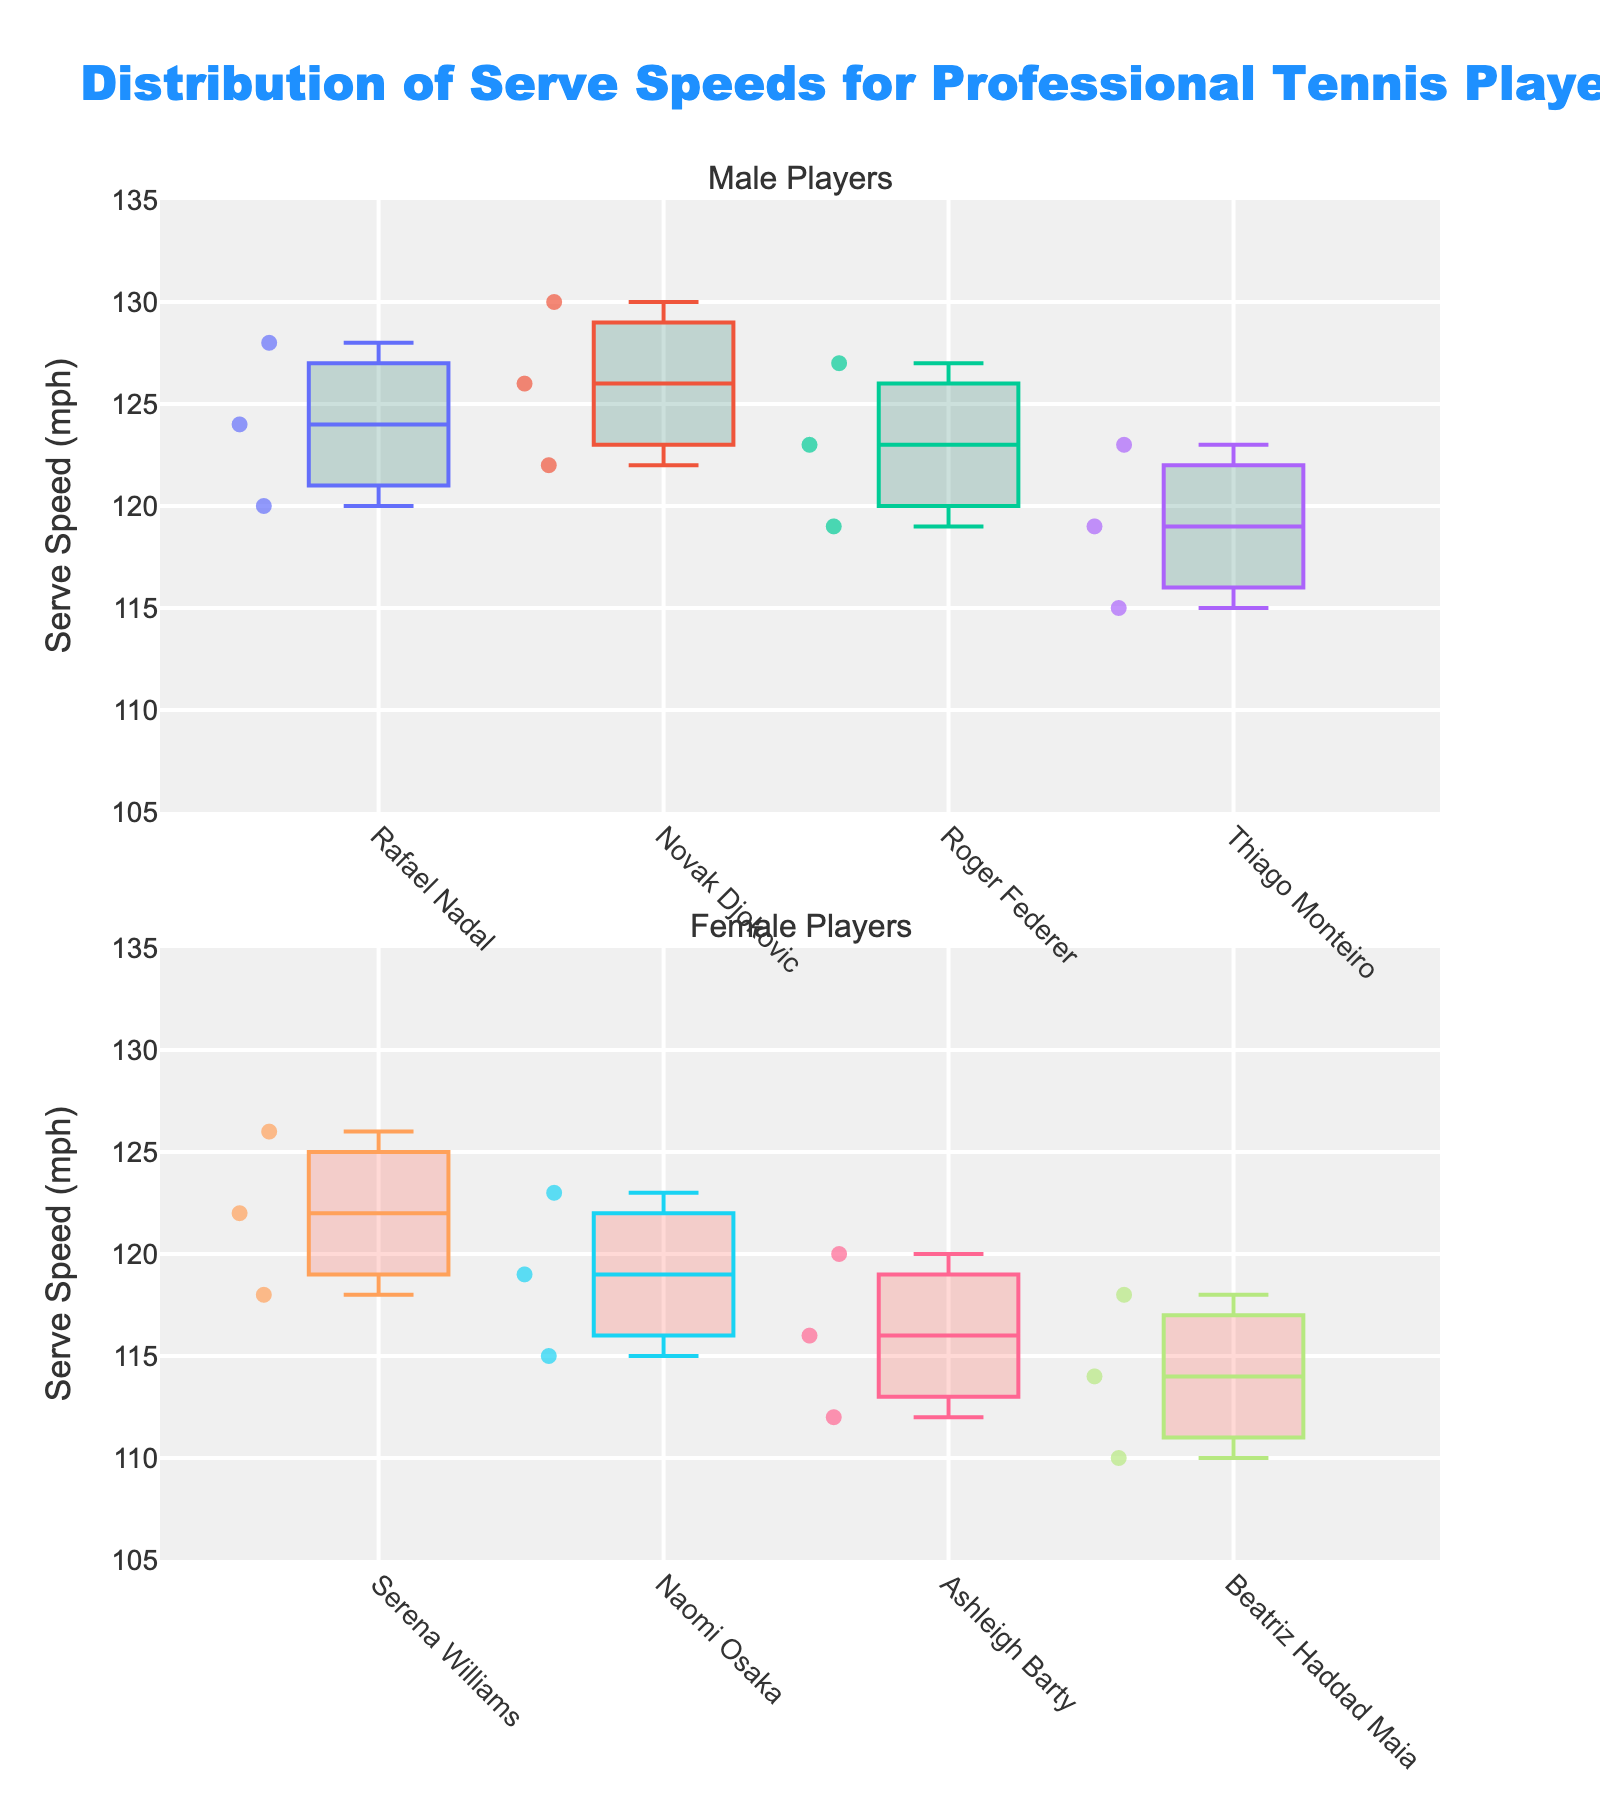What is the title of the figure? The title is displayed at the top of the figure. It reads "Distribution of Serve Speeds for Professional Tennis Players".
Answer: Distribution of Serve Speeds for Professional Tennis Players Which player has the widest range of serve speeds among male players? Examine the box plots of all male players from the top subplot. Rafael Nadal's box plot has the widest range.
Answer: Rafael Nadal Which female player has the lowest serve speed recorded? Look at the minimum values of the box plots in the female players' subplot. The lowest point is from Beatriz Haddad Maia.
Answer: Beatriz Haddad Maia How many players' serve speeds are displayed in the male players' subplot? Count the individual box plots displayed in the top subplot for male players.
Answer: 4 What is the median serve speed of Naomi Osaka based on the subplot? Identify the median line in Naomi Osaka's box plot in the bottom subplot.
Answer: 119 mph Which gender has a higher upper range of serve speeds? Compare the maximum values from both subplots. The highest maximum value in the male players' subplot is higher than in the female players' subplot.
Answer: Male Who has a higher average serve speed, Ashleigh Barty or Thiago Monteiro? Calculate the average from the individual serve speeds provided for Ashleigh Barty (112, 116, 120) and Thiago Monteiro (115, 119, 123), then compare them. Ashleigh Barty's average = (112 + 116 + 120) / 3 = 116 mph. Thiago Monteiro's average = (115 + 119 + 123) / 3 = 119 mph.
Answer: Thiago Monteiro Does Novak Djokovic have any serve speeds greater than 130 mph? Examine Novak Djokovic's box plot in the male players' subplot. The highest value is 130 mph, and there are no points above it.
Answer: No What is the serve speed range for Serena Williams? Identify the minimum and maximum values in Serena Williams' box plot. The range is from 118 mph to 126 mph.
Answer: 8 mph Which player among the female players has the most tightly clustered serves? Look for the player whose box plot has the smallest interquartile range (distance between the upper and lower quartiles). Ashleigh Barty's serves appear most tightly clustered.
Answer: Ashleigh Barty 